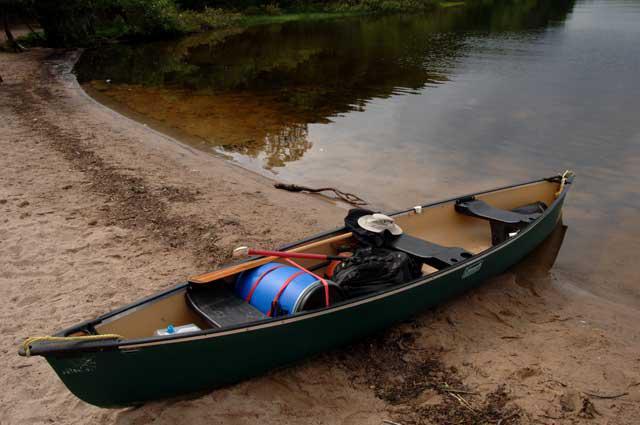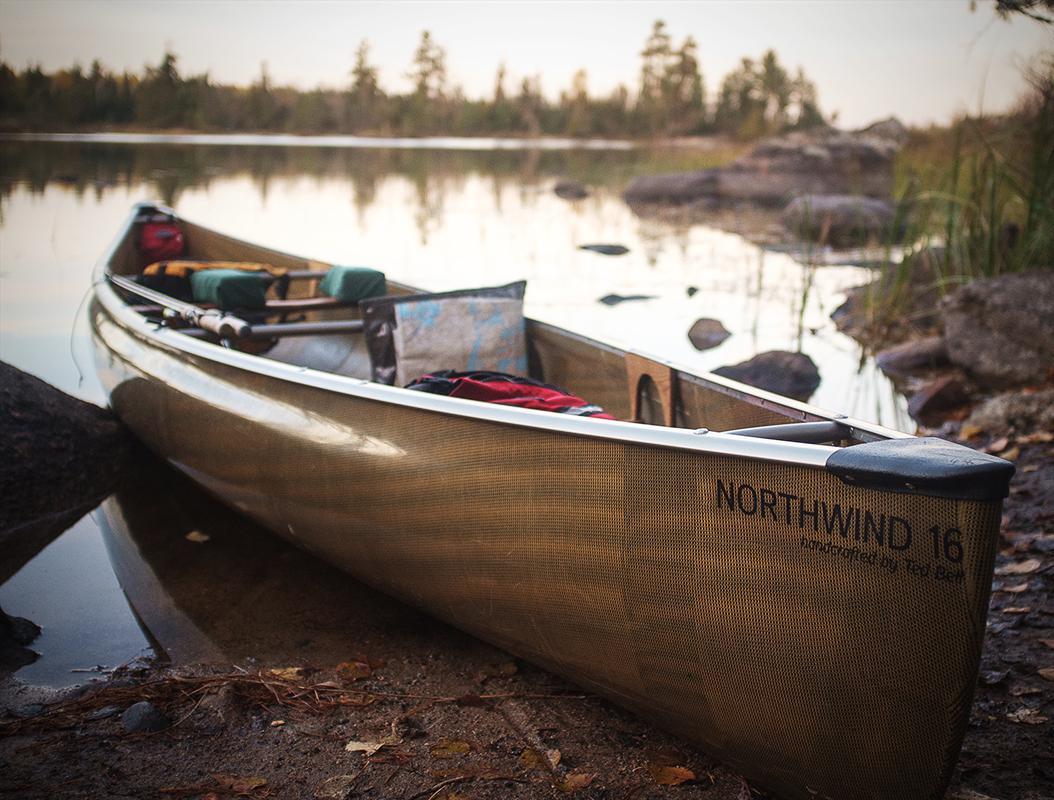The first image is the image on the left, the second image is the image on the right. For the images displayed, is the sentence "Each image shows in the foreground a boat containing gear pulled up to the water's edge so it is partly on ground." factually correct? Answer yes or no. Yes. The first image is the image on the left, the second image is the image on the right. Considering the images on both sides, is "At least one person is sitting in a canoe in the image on the right." valid? Answer yes or no. No. 